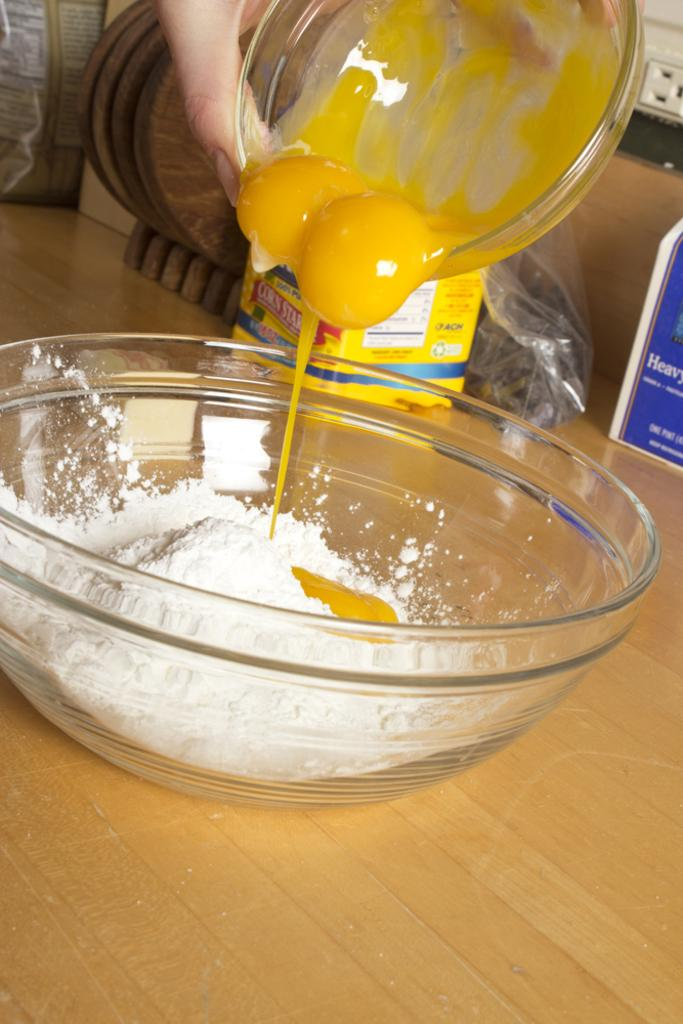What is in the first bowl that is visible in the image? There is a bowl with white powder in the image. What is in the second bowl that is visible in the image? There is another bowl with egg yolk in the image. How are the two bowls positioned in relation to each other? The two bowls are positioned above each other. What else can be seen in the background of the image? There are other objects visible in the background of the image. How does the beggar in the image value the form of the bowls? There is no beggar present in the image, so it is not possible to answer that question. 